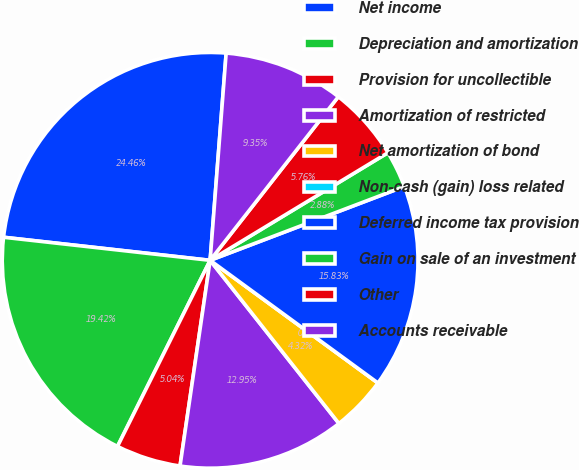<chart> <loc_0><loc_0><loc_500><loc_500><pie_chart><fcel>Net income<fcel>Depreciation and amortization<fcel>Provision for uncollectible<fcel>Amortization of restricted<fcel>Net amortization of bond<fcel>Non-cash (gain) loss related<fcel>Deferred income tax provision<fcel>Gain on sale of an investment<fcel>Other<fcel>Accounts receivable<nl><fcel>24.46%<fcel>19.42%<fcel>5.04%<fcel>12.95%<fcel>4.32%<fcel>0.0%<fcel>15.83%<fcel>2.88%<fcel>5.76%<fcel>9.35%<nl></chart> 